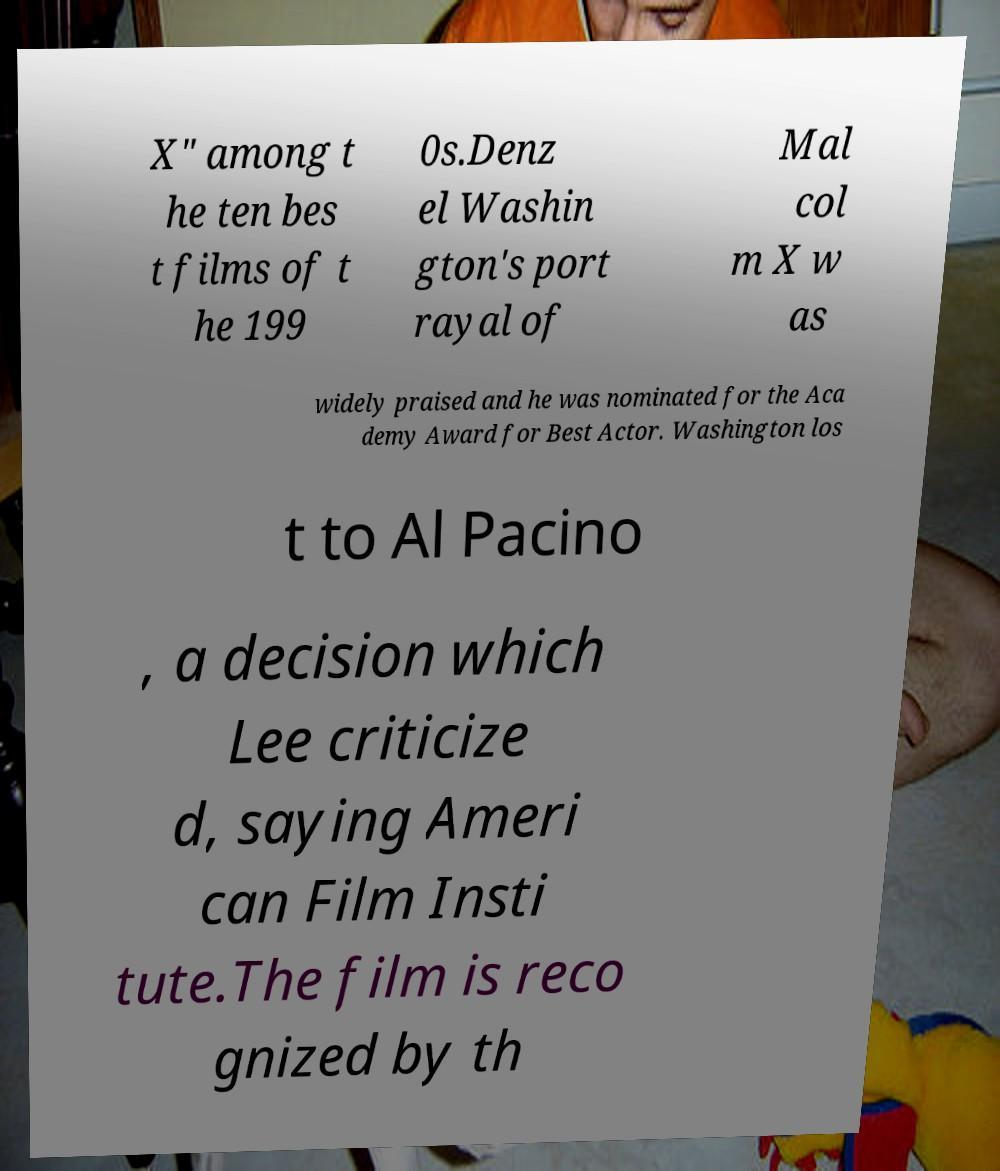There's text embedded in this image that I need extracted. Can you transcribe it verbatim? X" among t he ten bes t films of t he 199 0s.Denz el Washin gton's port rayal of Mal col m X w as widely praised and he was nominated for the Aca demy Award for Best Actor. Washington los t to Al Pacino , a decision which Lee criticize d, saying Ameri can Film Insti tute.The film is reco gnized by th 